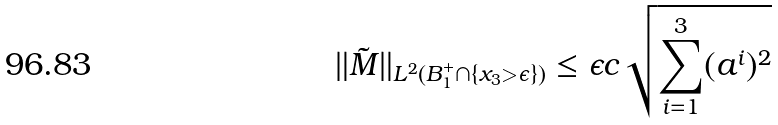Convert formula to latex. <formula><loc_0><loc_0><loc_500><loc_500>\| \tilde { M } \| _ { L ^ { 2 } ( B _ { 1 } ^ { + } \cap \{ x _ { 3 } > \epsilon \} ) } \leq \epsilon c \sqrt { \sum _ { i = 1 } ^ { 3 } ( a ^ { i } ) ^ { 2 } }</formula> 